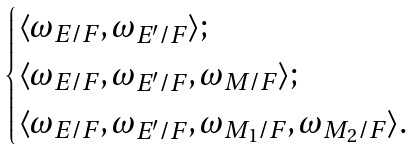<formula> <loc_0><loc_0><loc_500><loc_500>\begin{cases} \langle \omega _ { E / F } , \omega _ { E ^ { \prime } / F } \rangle ; \\ \langle \omega _ { E / F } , \omega _ { E ^ { \prime } / F } , \omega _ { M / F } \rangle ; \\ \langle \omega _ { E / F } , \omega _ { E ^ { \prime } / F } , \omega _ { M _ { 1 } / F } , \omega _ { M _ { 2 } / F } \rangle . \end{cases}</formula> 